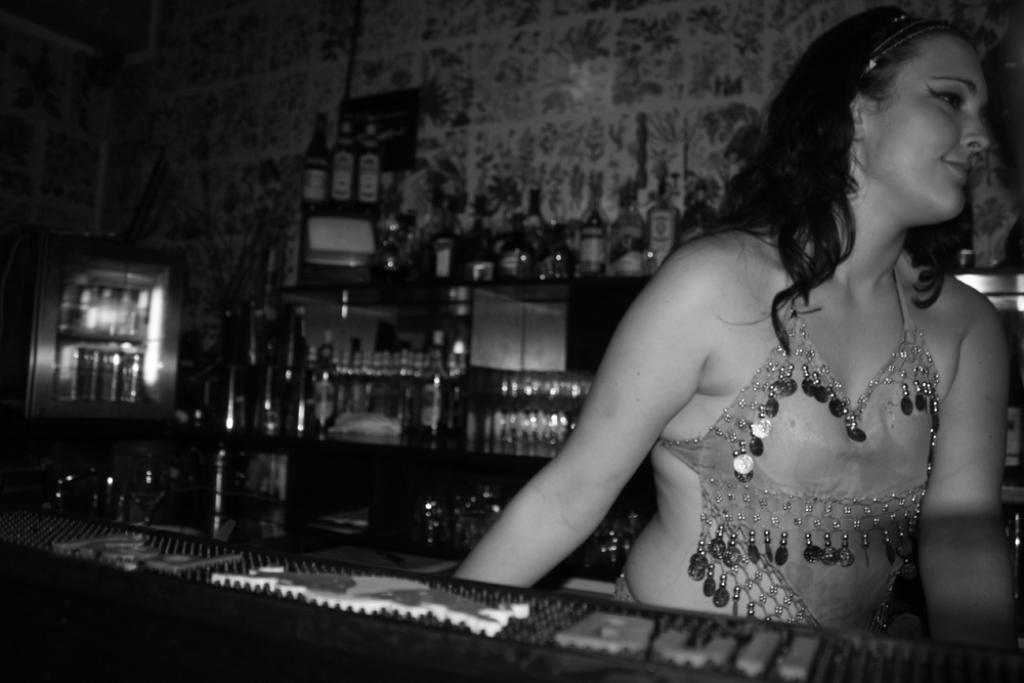What is the color scheme of the image? The image is black and white. Can you describe the woman's position in the image? The woman is standing beside a table. What can be seen on the backside of the image? There is a group of bottles placed in the racks on the backside. What is visible in the background of the image? There is a wall visible in the image. What type of instrument is the woman playing in the image? There is no instrument present in the image, and the woman is not playing any instrument. How many crows can be seen perched on the wall in the image? There are no crows visible in the image; only a wall is present in the background. 